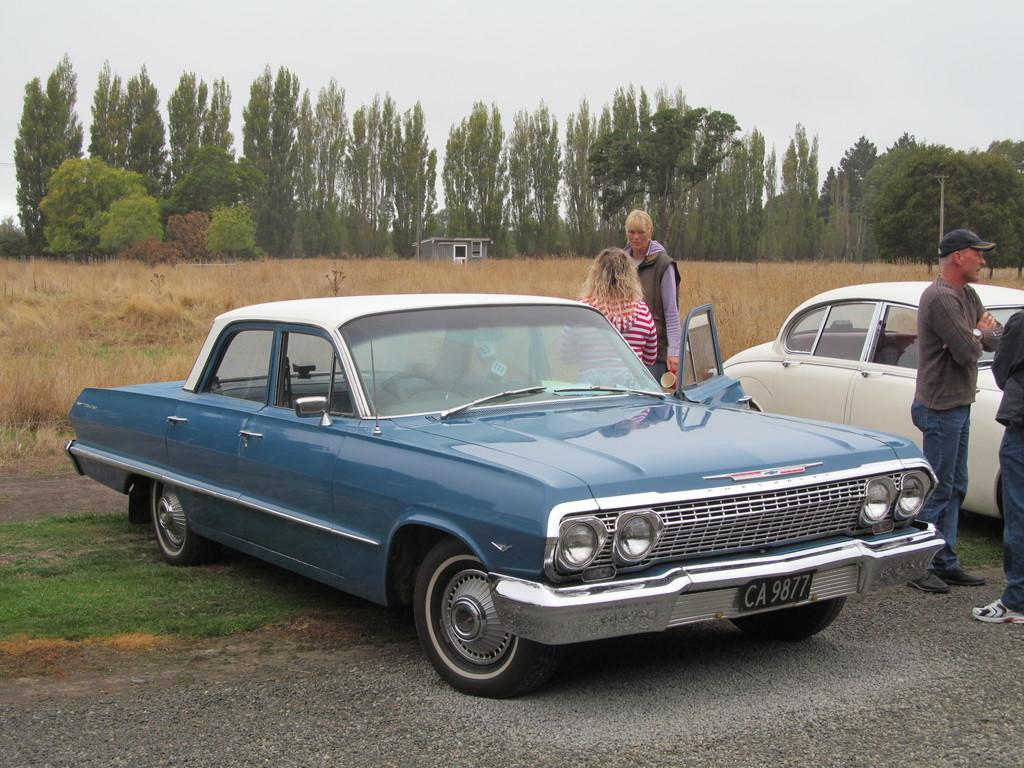What is happening in the image? There is a group of people standing in the image. What vehicle can be seen in the image? There is a gray car in the image. What type of vegetation is visible in the background of the image? There are trees in the background of the image. What is the color of the trees? The trees are green. What is visible in the sky in the background of the image? The sky is visible in the background of the image. What is the color of the sky? The sky is white. Can you see a kitty playing with a toad in the image? There is no kitty or toad present in the image. What type of cream is being served to the group of people in the image? There is no cream being served in the image; the group of people is standing without any food or drink visible. 